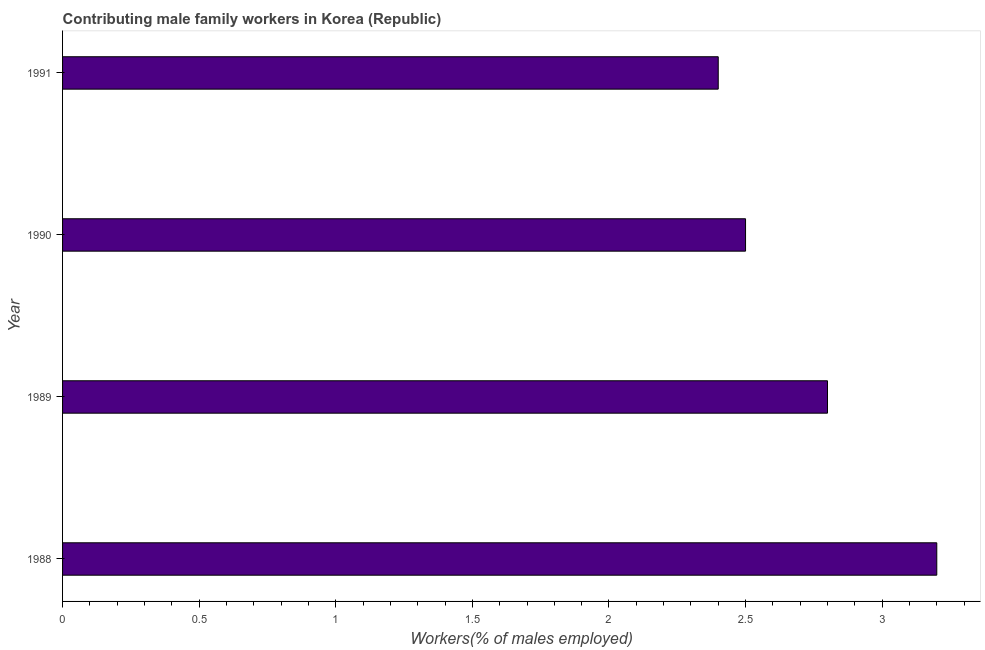Does the graph contain grids?
Offer a very short reply. No. What is the title of the graph?
Offer a very short reply. Contributing male family workers in Korea (Republic). What is the label or title of the X-axis?
Offer a terse response. Workers(% of males employed). What is the contributing male family workers in 1988?
Your answer should be very brief. 3.2. Across all years, what is the maximum contributing male family workers?
Your answer should be very brief. 3.2. Across all years, what is the minimum contributing male family workers?
Keep it short and to the point. 2.4. In which year was the contributing male family workers minimum?
Make the answer very short. 1991. What is the sum of the contributing male family workers?
Provide a succinct answer. 10.9. What is the average contributing male family workers per year?
Provide a short and direct response. 2.73. What is the median contributing male family workers?
Offer a terse response. 2.65. In how many years, is the contributing male family workers greater than 1.6 %?
Keep it short and to the point. 4. Do a majority of the years between 1991 and 1988 (inclusive) have contributing male family workers greater than 2.2 %?
Provide a short and direct response. Yes. What is the ratio of the contributing male family workers in 1990 to that in 1991?
Your answer should be very brief. 1.04. Is the difference between the contributing male family workers in 1989 and 1990 greater than the difference between any two years?
Offer a very short reply. No. In how many years, is the contributing male family workers greater than the average contributing male family workers taken over all years?
Offer a very short reply. 2. How many bars are there?
Your answer should be compact. 4. Are all the bars in the graph horizontal?
Make the answer very short. Yes. How many years are there in the graph?
Your response must be concise. 4. What is the difference between two consecutive major ticks on the X-axis?
Your response must be concise. 0.5. What is the Workers(% of males employed) of 1988?
Your answer should be very brief. 3.2. What is the Workers(% of males employed) in 1989?
Keep it short and to the point. 2.8. What is the Workers(% of males employed) in 1990?
Your response must be concise. 2.5. What is the Workers(% of males employed) in 1991?
Your response must be concise. 2.4. What is the difference between the Workers(% of males employed) in 1988 and 1990?
Your response must be concise. 0.7. What is the difference between the Workers(% of males employed) in 1990 and 1991?
Your answer should be very brief. 0.1. What is the ratio of the Workers(% of males employed) in 1988 to that in 1989?
Ensure brevity in your answer.  1.14. What is the ratio of the Workers(% of males employed) in 1988 to that in 1990?
Your answer should be compact. 1.28. What is the ratio of the Workers(% of males employed) in 1988 to that in 1991?
Your answer should be very brief. 1.33. What is the ratio of the Workers(% of males employed) in 1989 to that in 1990?
Ensure brevity in your answer.  1.12. What is the ratio of the Workers(% of males employed) in 1989 to that in 1991?
Keep it short and to the point. 1.17. What is the ratio of the Workers(% of males employed) in 1990 to that in 1991?
Give a very brief answer. 1.04. 